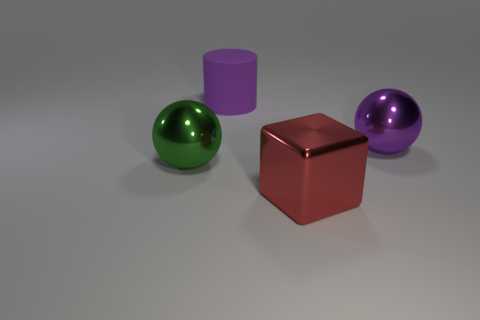There is a big sphere that is the same color as the cylinder; what material is it? The big sphere appears to share the glossy, reflective quality with the cylinder, suggesting that it could be made of a polished metal, possibly with a coating or treatment to give it a vibrant color. 